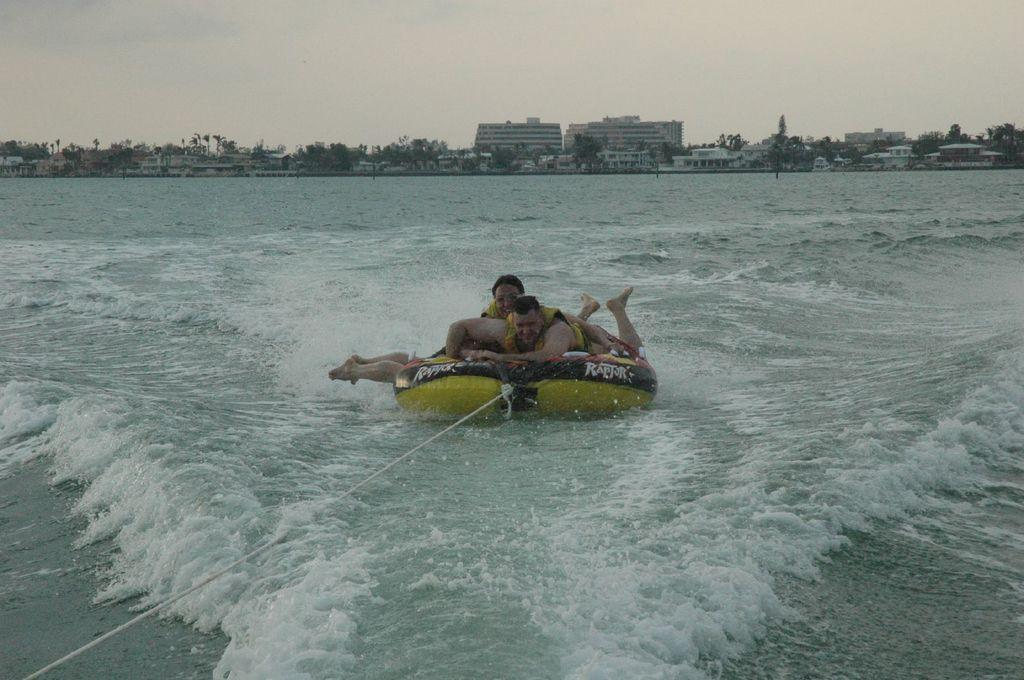How many people are in the image? There are two people in the image. What are the people doing in the image? The people are on an inflatable boat. Is the boat secured in any way? Yes, the boat is tied with a rope. What type of environment is visible in the image? There is water, buildings, and trees visible in the image. What type of lace is being used to decorate the quill in the image? There is no lace or quill present in the image; it features two people on an inflatable boat in a watery environment with buildings and trees. 